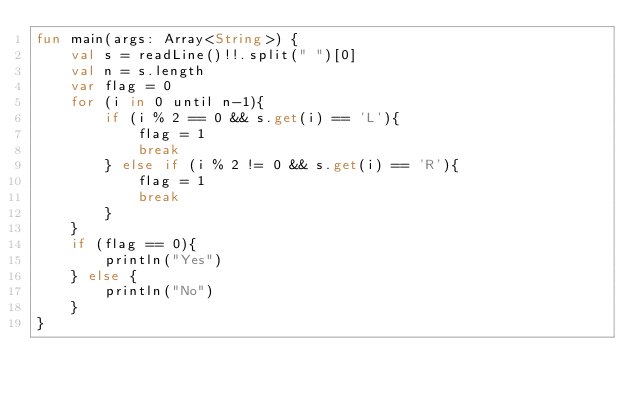<code> <loc_0><loc_0><loc_500><loc_500><_Kotlin_>fun main(args: Array<String>) {
    val s = readLine()!!.split(" ")[0]
    val n = s.length
    var flag = 0
    for (i in 0 until n-1){
        if (i % 2 == 0 && s.get(i) == 'L'){
            flag = 1
            break
        } else if (i % 2 != 0 && s.get(i) == 'R'){
            flag = 1
            break
        }
    }
    if (flag == 0){
        println("Yes")
    } else {
        println("No")
    }
}</code> 